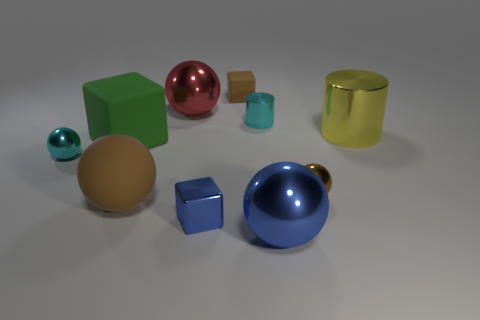How many things are brown rubber balls that are in front of the big green matte object or spheres that are right of the green object?
Give a very brief answer. 4. There is a rubber ball that is the same size as the red shiny object; what is its color?
Provide a succinct answer. Brown. Is the material of the yellow cylinder the same as the small blue cube?
Ensure brevity in your answer.  Yes. There is a tiny block that is left of the brown rubber object behind the tiny brown shiny ball; what is it made of?
Provide a succinct answer. Metal. Are there more cyan balls that are in front of the tiny cylinder than objects?
Keep it short and to the point. No. What number of other objects are the same size as the blue shiny cube?
Make the answer very short. 4. Is the color of the big cylinder the same as the large rubber block?
Your answer should be compact. No. What is the color of the cylinder left of the big ball to the right of the tiny brown matte cube that is to the right of the tiny blue metal cube?
Make the answer very short. Cyan. What number of tiny cyan spheres are in front of the shiny thing that is on the left side of the large metallic thing that is on the left side of the tiny brown cube?
Give a very brief answer. 0. Is there any other thing that has the same color as the metallic cube?
Ensure brevity in your answer.  Yes. 